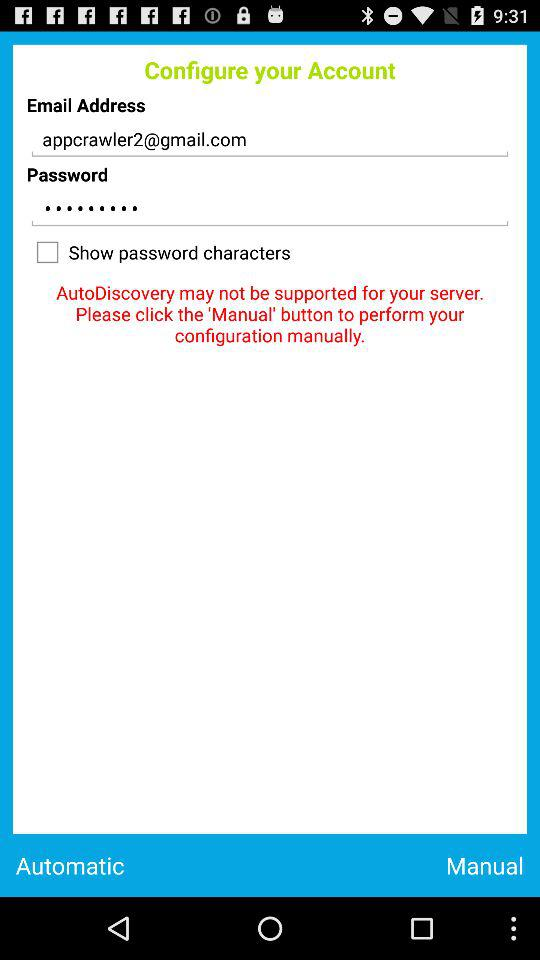What is the email address? The email address is "appcrawler2@gmail.com". 